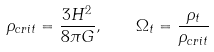Convert formula to latex. <formula><loc_0><loc_0><loc_500><loc_500>\rho _ { c r i t } = \frac { 3 H ^ { 2 } } { 8 \pi G } , \quad \Omega _ { t } = \frac { \rho _ { t } } { \rho _ { c r i t } }</formula> 